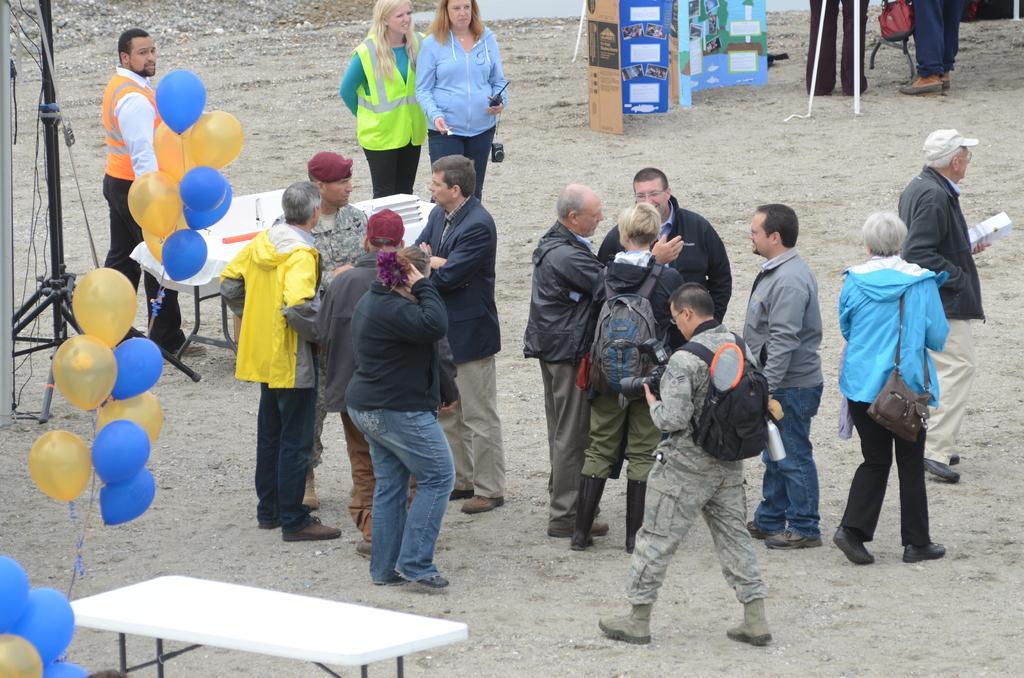How would you summarize this image in a sentence or two? In this image there is a group of people standing and talking with each other, in this image there is a camera stand, tables and balloons. 